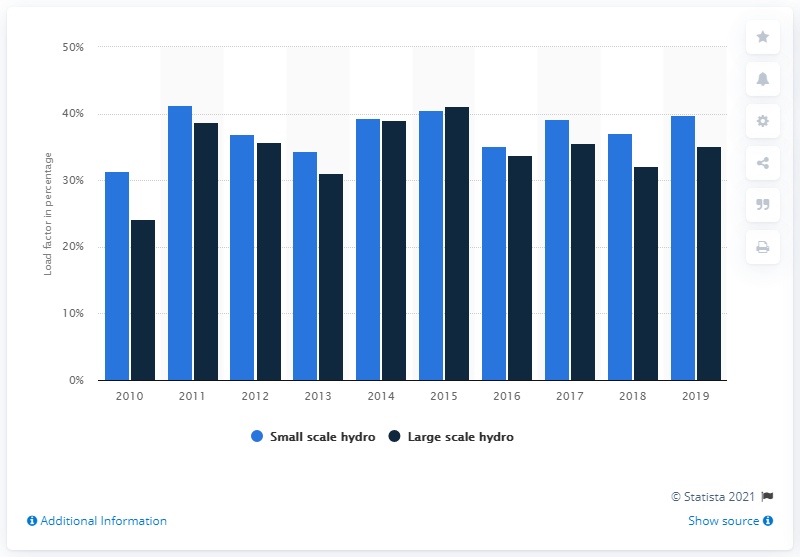List a handful of essential elements in this visual. Load factors for large-scale hydropower were lower in 2015. In 2019, the load factor of small-scale hydroelectricity was 39.8%. The load factor for electricity generation from small-scale and large-scale hydropower in the UK began to fluctuate in 2010. 